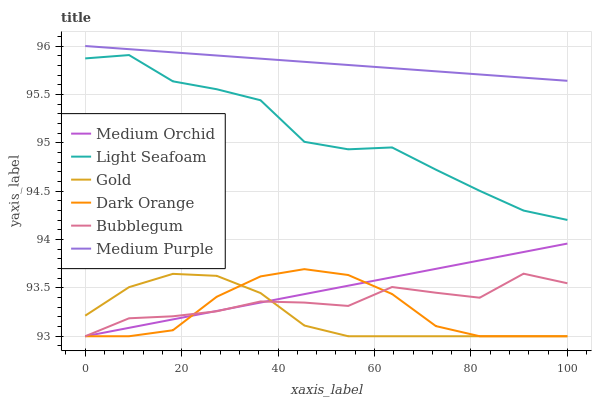Does Gold have the minimum area under the curve?
Answer yes or no. Yes. Does Medium Purple have the maximum area under the curve?
Answer yes or no. Yes. Does Medium Orchid have the minimum area under the curve?
Answer yes or no. No. Does Medium Orchid have the maximum area under the curve?
Answer yes or no. No. Is Medium Purple the smoothest?
Answer yes or no. Yes. Is Light Seafoam the roughest?
Answer yes or no. Yes. Is Gold the smoothest?
Answer yes or no. No. Is Gold the roughest?
Answer yes or no. No. Does Dark Orange have the lowest value?
Answer yes or no. Yes. Does Medium Purple have the lowest value?
Answer yes or no. No. Does Medium Purple have the highest value?
Answer yes or no. Yes. Does Medium Orchid have the highest value?
Answer yes or no. No. Is Bubblegum less than Light Seafoam?
Answer yes or no. Yes. Is Medium Purple greater than Bubblegum?
Answer yes or no. Yes. Does Dark Orange intersect Gold?
Answer yes or no. Yes. Is Dark Orange less than Gold?
Answer yes or no. No. Is Dark Orange greater than Gold?
Answer yes or no. No. Does Bubblegum intersect Light Seafoam?
Answer yes or no. No. 